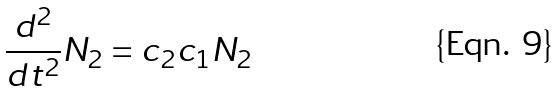Convert formula to latex. <formula><loc_0><loc_0><loc_500><loc_500>\frac { d ^ { 2 } } { d t ^ { 2 } } N _ { 2 } = c _ { 2 } c _ { 1 } N _ { 2 }</formula> 